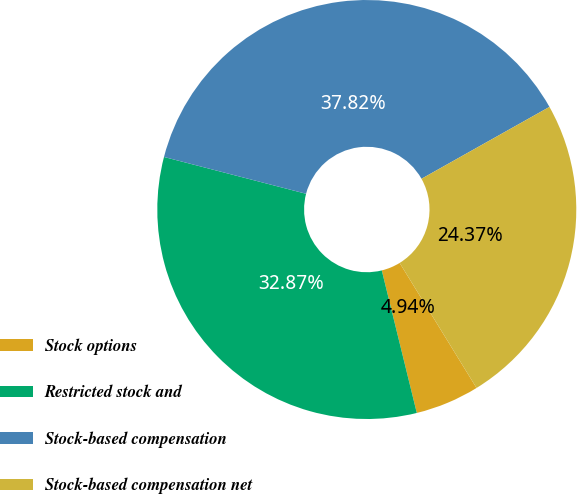Convert chart to OTSL. <chart><loc_0><loc_0><loc_500><loc_500><pie_chart><fcel>Stock options<fcel>Restricted stock and<fcel>Stock-based compensation<fcel>Stock-based compensation net<nl><fcel>4.94%<fcel>32.87%<fcel>37.82%<fcel>24.37%<nl></chart> 